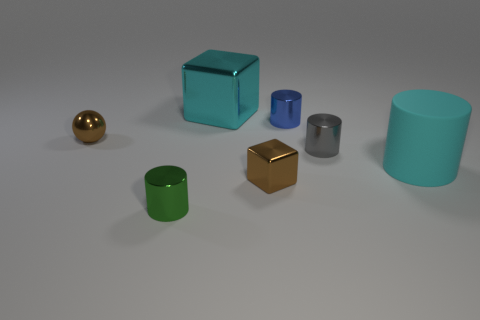Do the brown thing that is to the left of the large block and the large cyan thing that is behind the blue thing have the same shape? no 